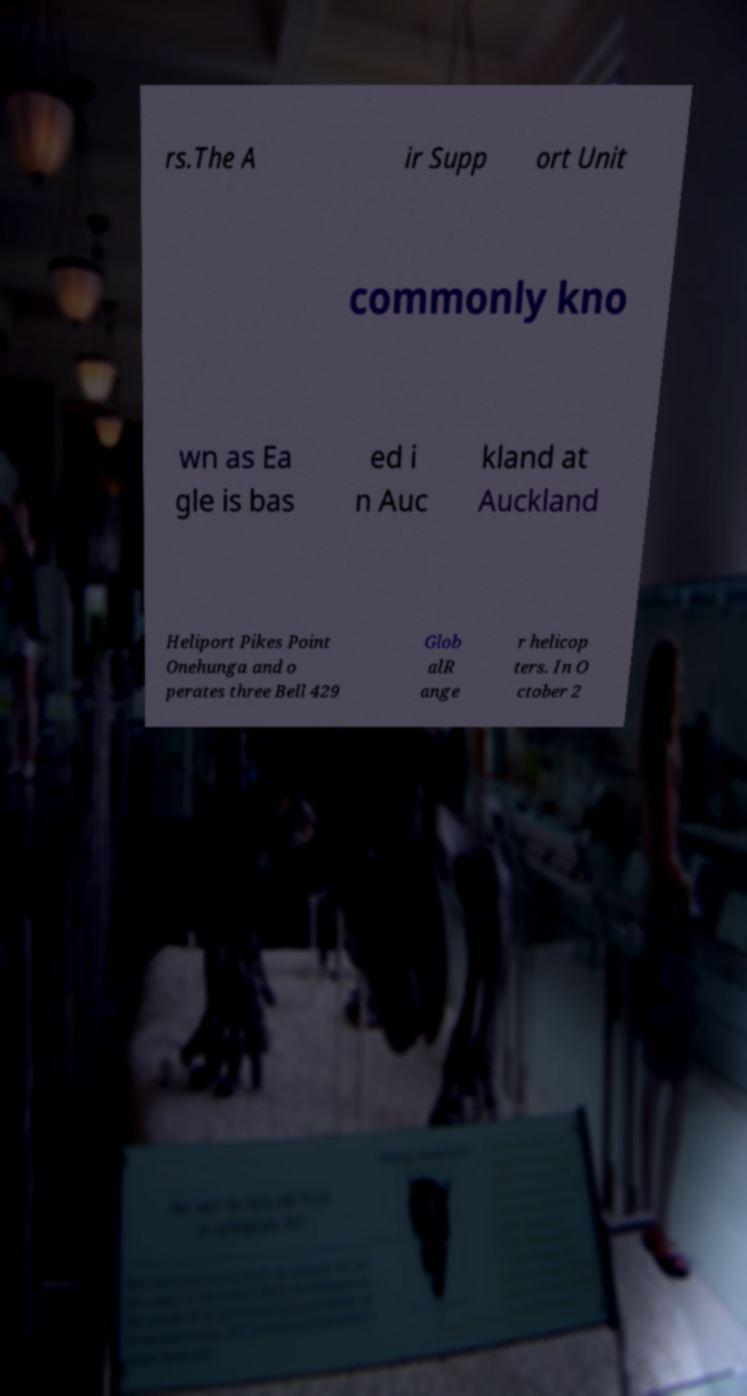For documentation purposes, I need the text within this image transcribed. Could you provide that? rs.The A ir Supp ort Unit commonly kno wn as Ea gle is bas ed i n Auc kland at Auckland Heliport Pikes Point Onehunga and o perates three Bell 429 Glob alR ange r helicop ters. In O ctober 2 